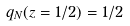<formula> <loc_0><loc_0><loc_500><loc_500>q _ { N } ( z = 1 / 2 ) = 1 / 2</formula> 